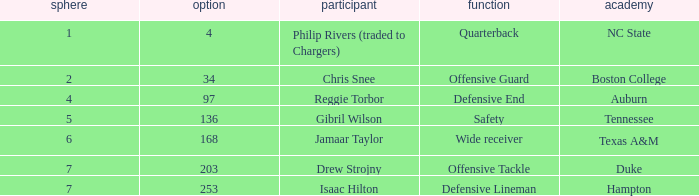In which role does a player of gibril wilson's caliber perform? Safety. 